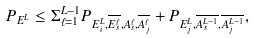<formula> <loc_0><loc_0><loc_500><loc_500>P _ { E ^ { L } } & \leq \Sigma _ { \ell = 1 } ^ { L - 1 } P _ { E _ { i } ^ { L } , \overline { E _ { s } ^ { \ell } } , A _ { s } ^ { \ell } , \overline { A _ { j } ^ { \ell } } } + P _ { E _ { j } ^ { L } , \overline { A _ { s } ^ { L - 1 } } , \overline { A _ { j } ^ { L - 1 } } } ,</formula> 